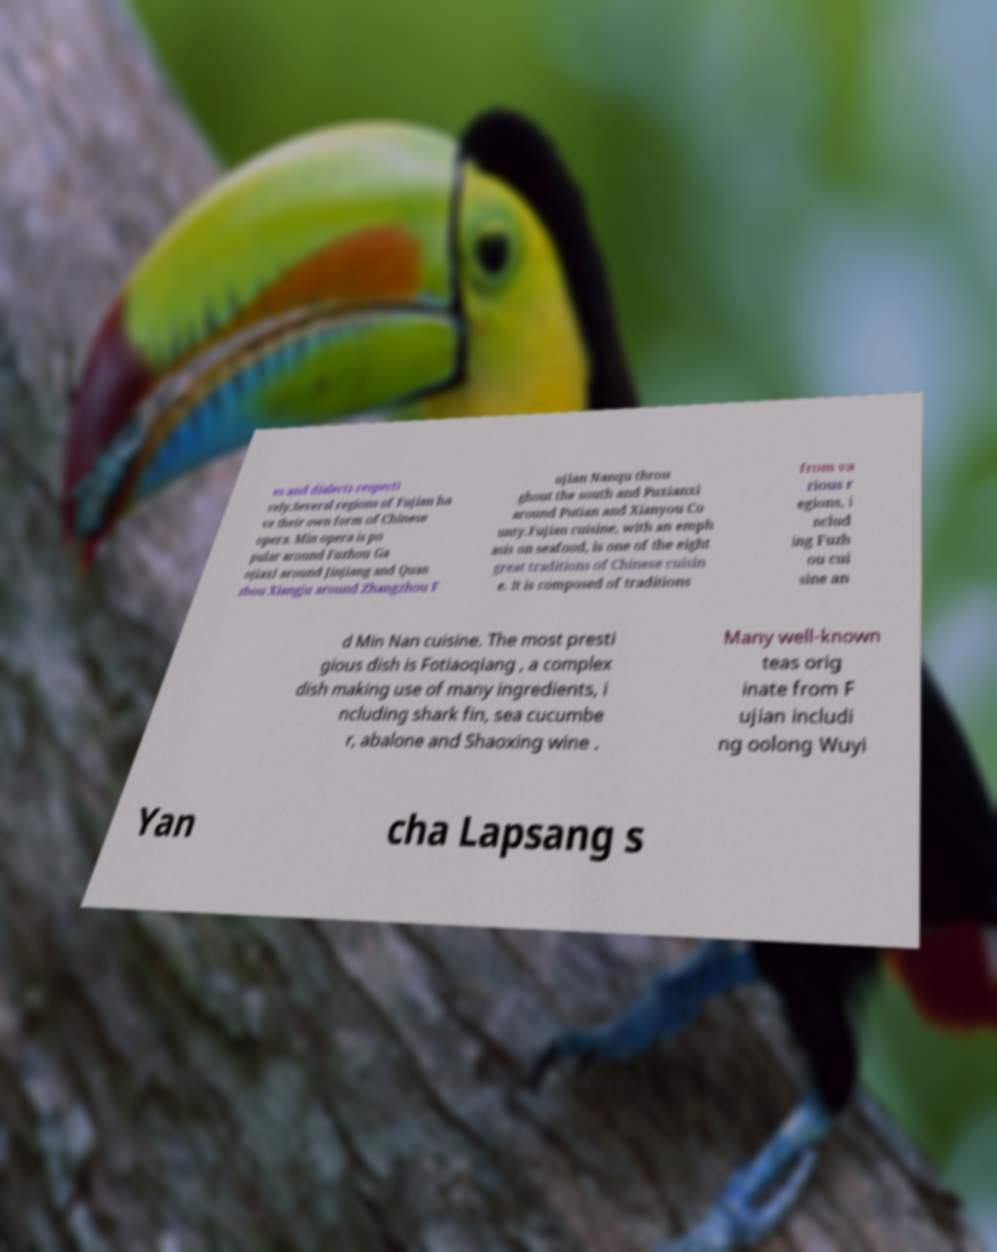Can you read and provide the text displayed in the image?This photo seems to have some interesting text. Can you extract and type it out for me? es and dialects respecti vely.Several regions of Fujian ha ve their own form of Chinese opera. Min opera is po pular around Fuzhou Ga ojiaxi around Jinjiang and Quan zhou Xiangju around Zhangzhou F ujian Nanqu throu ghout the south and Puxianxi around Putian and Xianyou Co unty.Fujian cuisine, with an emph asis on seafood, is one of the eight great traditions of Chinese cuisin e. It is composed of traditions from va rious r egions, i nclud ing Fuzh ou cui sine an d Min Nan cuisine. The most presti gious dish is Fotiaoqiang , a complex dish making use of many ingredients, i ncluding shark fin, sea cucumbe r, abalone and Shaoxing wine . Many well-known teas orig inate from F ujian includi ng oolong Wuyi Yan cha Lapsang s 